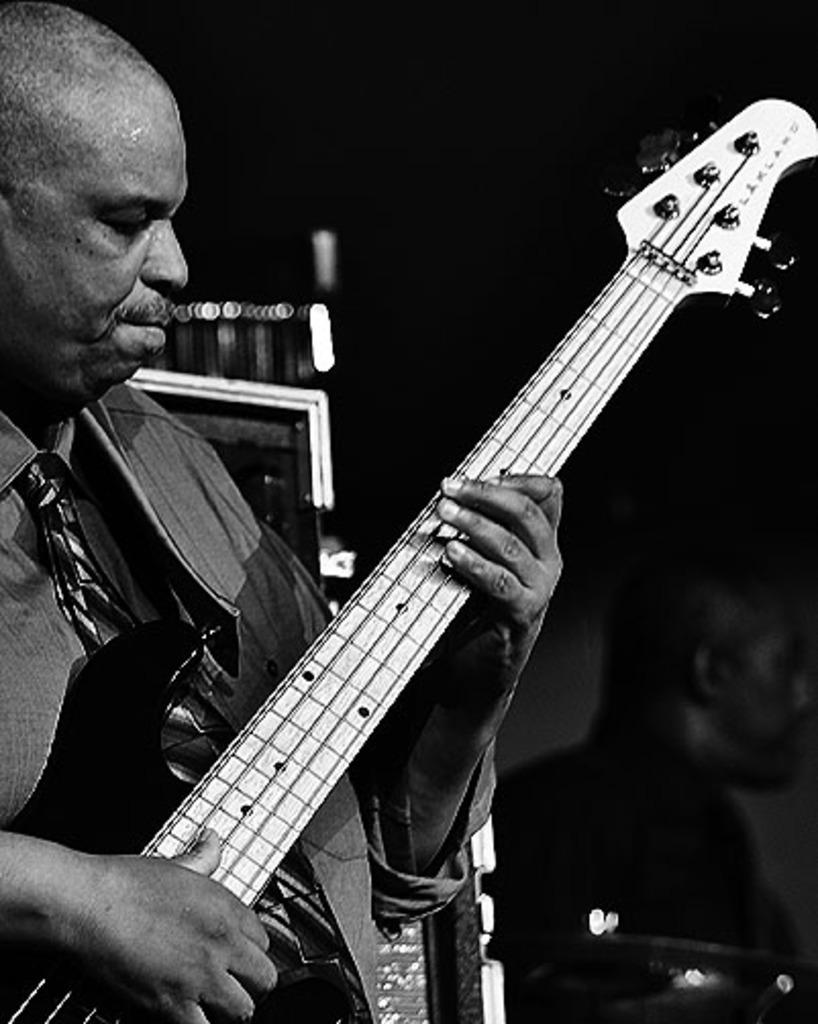What is the person in the image doing? The person is standing and playing a guitar. Can you describe the position of the chair in the image? There is a chair on the right side of the person. What else can be seen in the background of the image? Musical instruments are visible in the background. What type of bone is being used as a pick for the guitar in the image? There is no bone being used as a pick for the guitar in the image; the person is using their fingers or a traditional guitar pick. 